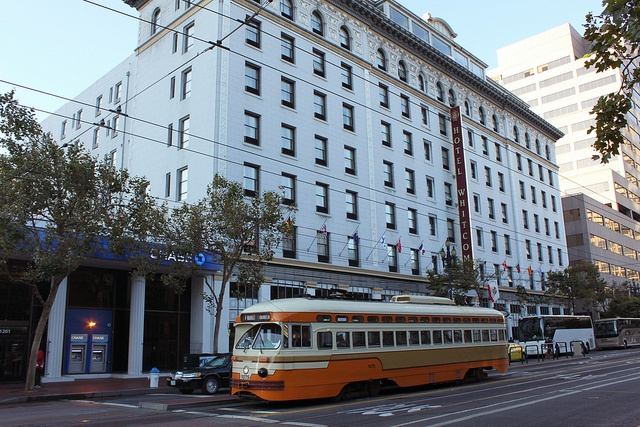Describe the objects in this image and their specific colors. I can see bus in lightblue, maroon, black, darkgray, and gray tones, bus in lightblue, black, gray, and darkgray tones, car in lightblue, black, and gray tones, bus in lightblue, black, and gray tones, and people in lightblue, black, maroon, and gray tones in this image. 